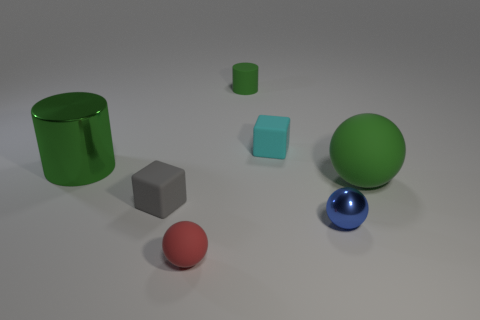Subtract 1 spheres. How many spheres are left? 2 Subtract all red balls. How many balls are left? 2 Add 1 tiny yellow rubber cylinders. How many objects exist? 8 Subtract all cubes. How many objects are left? 5 Subtract 0 yellow cylinders. How many objects are left? 7 Subtract all big purple cylinders. Subtract all green rubber cylinders. How many objects are left? 6 Add 5 large rubber spheres. How many large rubber spheres are left? 6 Add 3 tiny brown rubber balls. How many tiny brown rubber balls exist? 3 